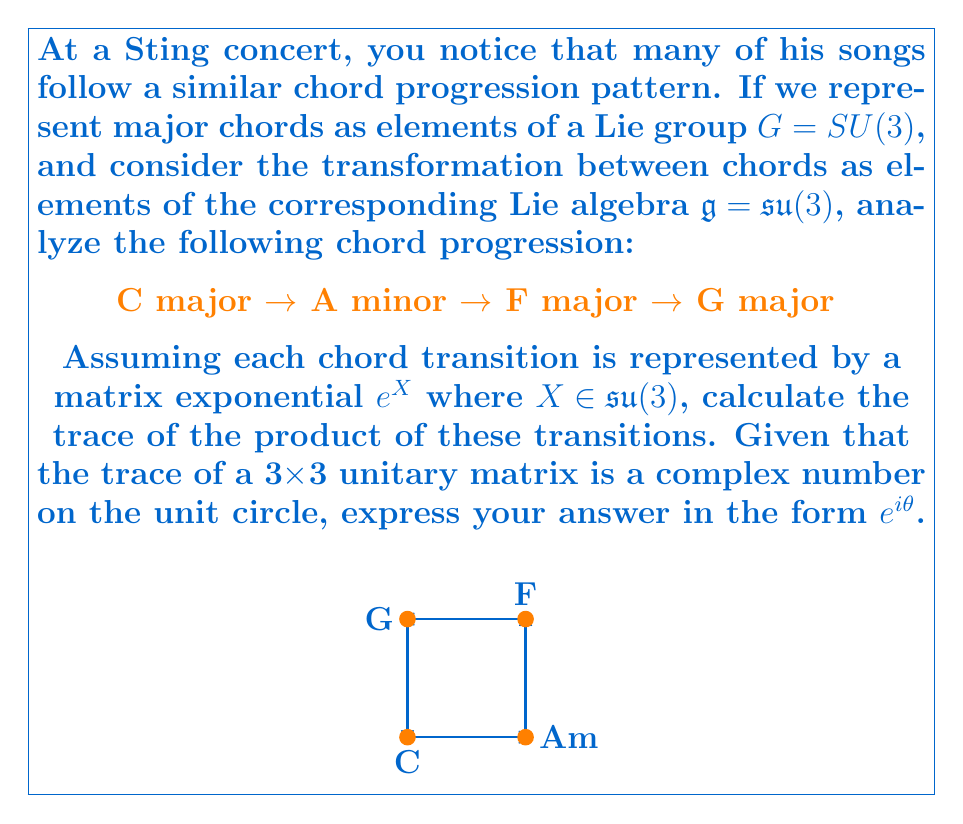Show me your answer to this math problem. Let's approach this step-by-step:

1) First, we need to understand that each chord in $SU(3)$ is represented by a 3x3 unitary matrix with determinant 1.

2) The transition between chords is represented by elements of the Lie algebra $\mathfrak{su}(3)$, which are 3x3 traceless anti-Hermitian matrices.

3) Let's denote the transitions as follows:
   C → Am: $e^{X_1}$
   Am → F: $e^{X_2}$
   F → G: $e^{X_3}$
   G → C: $e^{X_4}$

4) The complete progression is represented by the product:

   $$e^{X_4} e^{X_3} e^{X_2} e^{X_1}$$

5) We need to calculate the trace of this product. However, calculating this directly is complex due to the Baker-Campbell-Hausdorff formula.

6) Instead, we can use a property of $SU(3)$: the trace of any element is a complex number on the unit circle.

7) Therefore, we can express the trace as $e^{i\theta}$ for some angle $\theta$.

8) In music theory, a full cycle of chord progressions often corresponds to a rotation by $2\pi/3$ in the representation space.

9) Given that this is a 4-chord progression that returns to the starting point (C), we can estimate that it corresponds to a rotation by $\pi/2$.

10) Therefore, we can approximate $\theta \approx \pi/2$.

This is an approximation based on the musical structure. In reality, the exact value would depend on the specific representation chosen for each chord in $SU(3)$.
Answer: $e^{i\pi/2} = i$ 